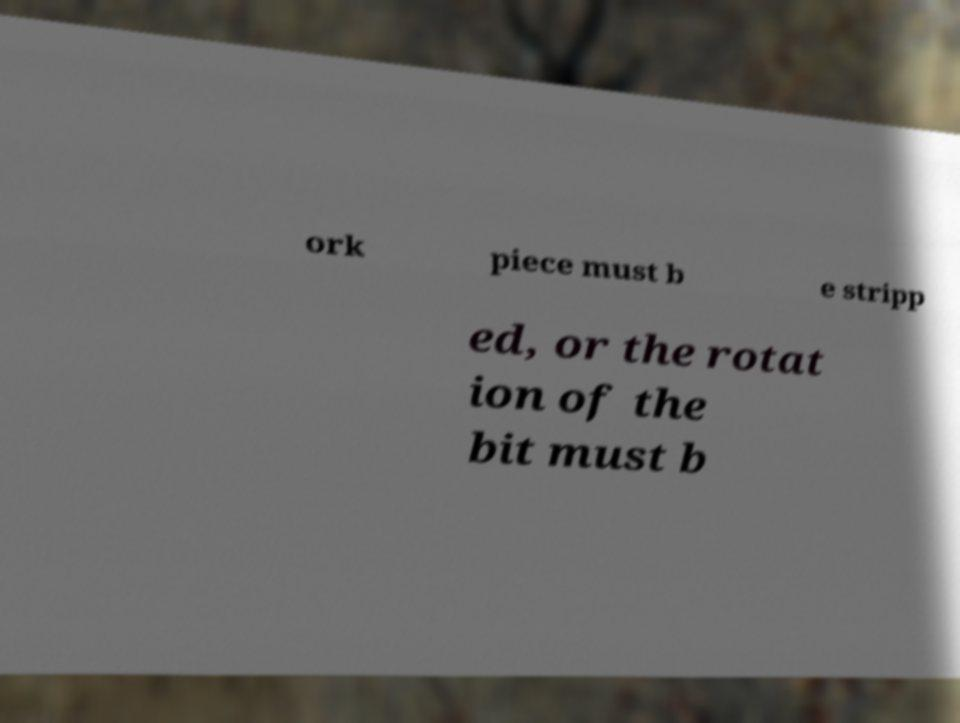Could you extract and type out the text from this image? ork piece must b e stripp ed, or the rotat ion of the bit must b 